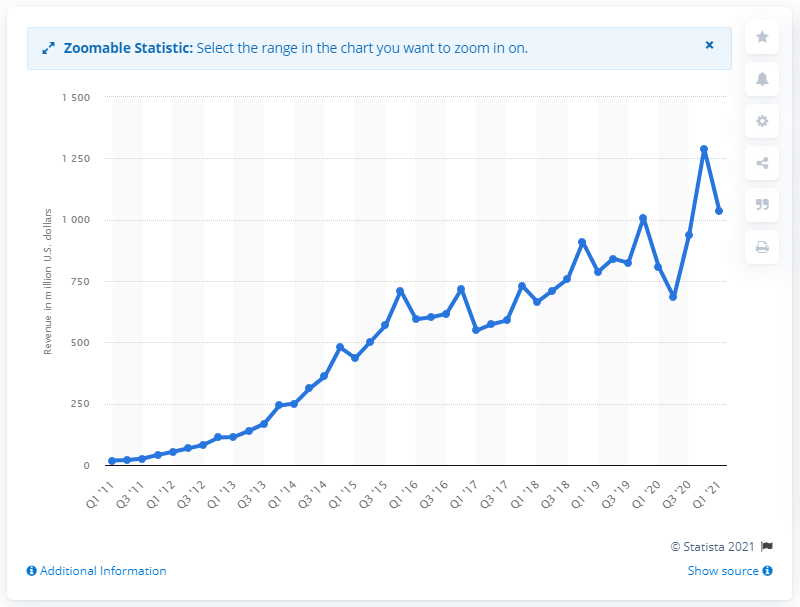List a handful of essential elements in this visual. In the first quarter of 2021, Twitter's revenue was 1036.02 dollars. 